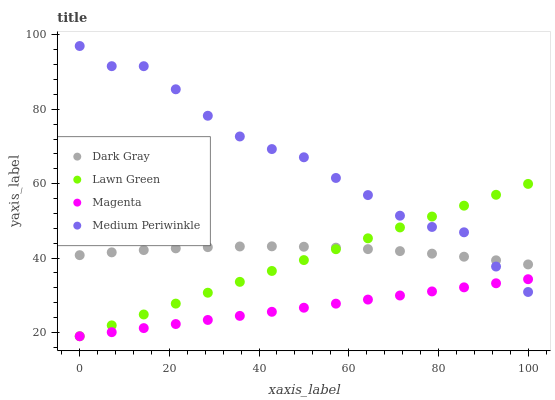Does Magenta have the minimum area under the curve?
Answer yes or no. Yes. Does Medium Periwinkle have the maximum area under the curve?
Answer yes or no. Yes. Does Lawn Green have the minimum area under the curve?
Answer yes or no. No. Does Lawn Green have the maximum area under the curve?
Answer yes or no. No. Is Magenta the smoothest?
Answer yes or no. Yes. Is Medium Periwinkle the roughest?
Answer yes or no. Yes. Is Lawn Green the smoothest?
Answer yes or no. No. Is Lawn Green the roughest?
Answer yes or no. No. Does Lawn Green have the lowest value?
Answer yes or no. Yes. Does Medium Periwinkle have the lowest value?
Answer yes or no. No. Does Medium Periwinkle have the highest value?
Answer yes or no. Yes. Does Lawn Green have the highest value?
Answer yes or no. No. Is Magenta less than Dark Gray?
Answer yes or no. Yes. Is Dark Gray greater than Magenta?
Answer yes or no. Yes. Does Magenta intersect Lawn Green?
Answer yes or no. Yes. Is Magenta less than Lawn Green?
Answer yes or no. No. Is Magenta greater than Lawn Green?
Answer yes or no. No. Does Magenta intersect Dark Gray?
Answer yes or no. No. 